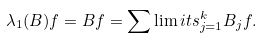<formula> <loc_0><loc_0><loc_500><loc_500>& \lambda _ { 1 } ( B ) f = B f = \sum \lim i t s _ { j = 1 } ^ { k } B _ { j } f .</formula> 